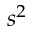Convert formula to latex. <formula><loc_0><loc_0><loc_500><loc_500>s ^ { 2 }</formula> 